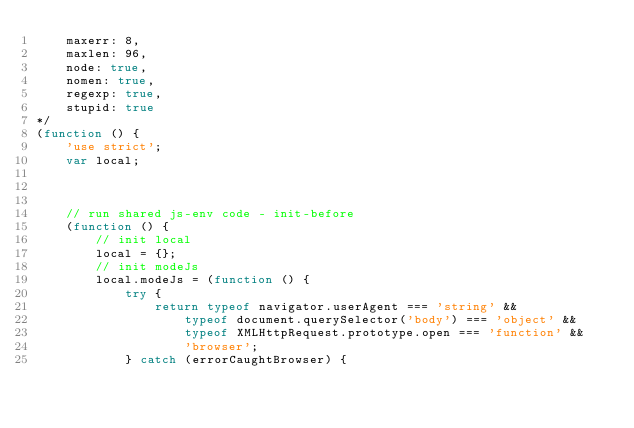Convert code to text. <code><loc_0><loc_0><loc_500><loc_500><_JavaScript_>    maxerr: 8,
    maxlen: 96,
    node: true,
    nomen: true,
    regexp: true,
    stupid: true
*/
(function () {
    'use strict';
    var local;



    // run shared js-env code - init-before
    (function () {
        // init local
        local = {};
        // init modeJs
        local.modeJs = (function () {
            try {
                return typeof navigator.userAgent === 'string' &&
                    typeof document.querySelector('body') === 'object' &&
                    typeof XMLHttpRequest.prototype.open === 'function' &&
                    'browser';
            } catch (errorCaughtBrowser) {</code> 